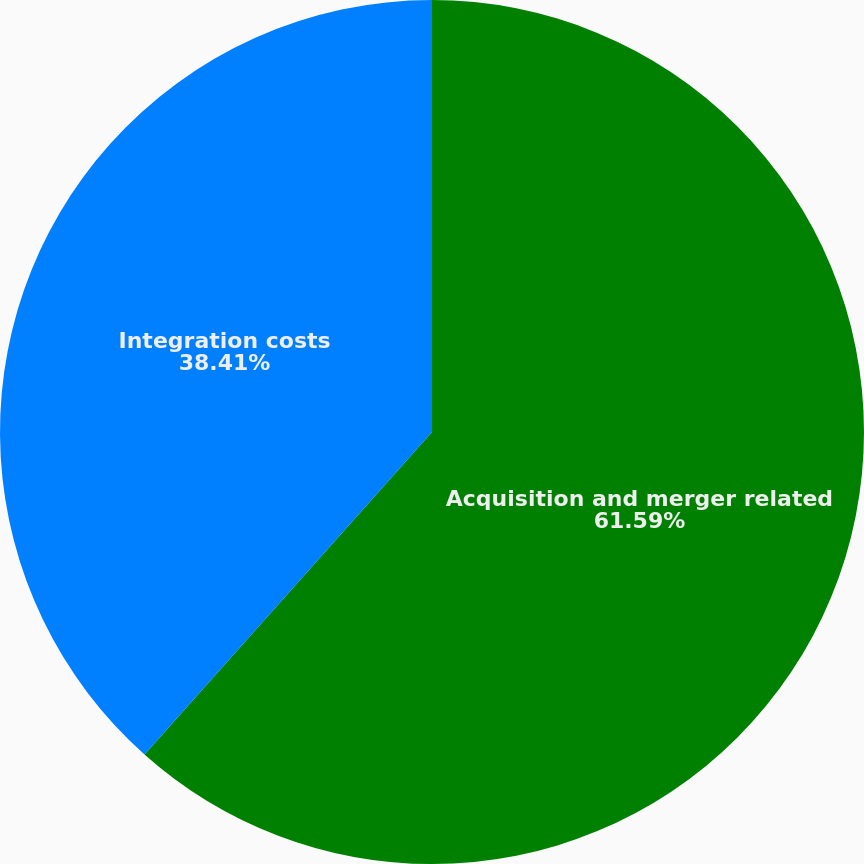<chart> <loc_0><loc_0><loc_500><loc_500><pie_chart><fcel>Acquisition and merger related<fcel>Integration costs<nl><fcel>61.59%<fcel>38.41%<nl></chart> 